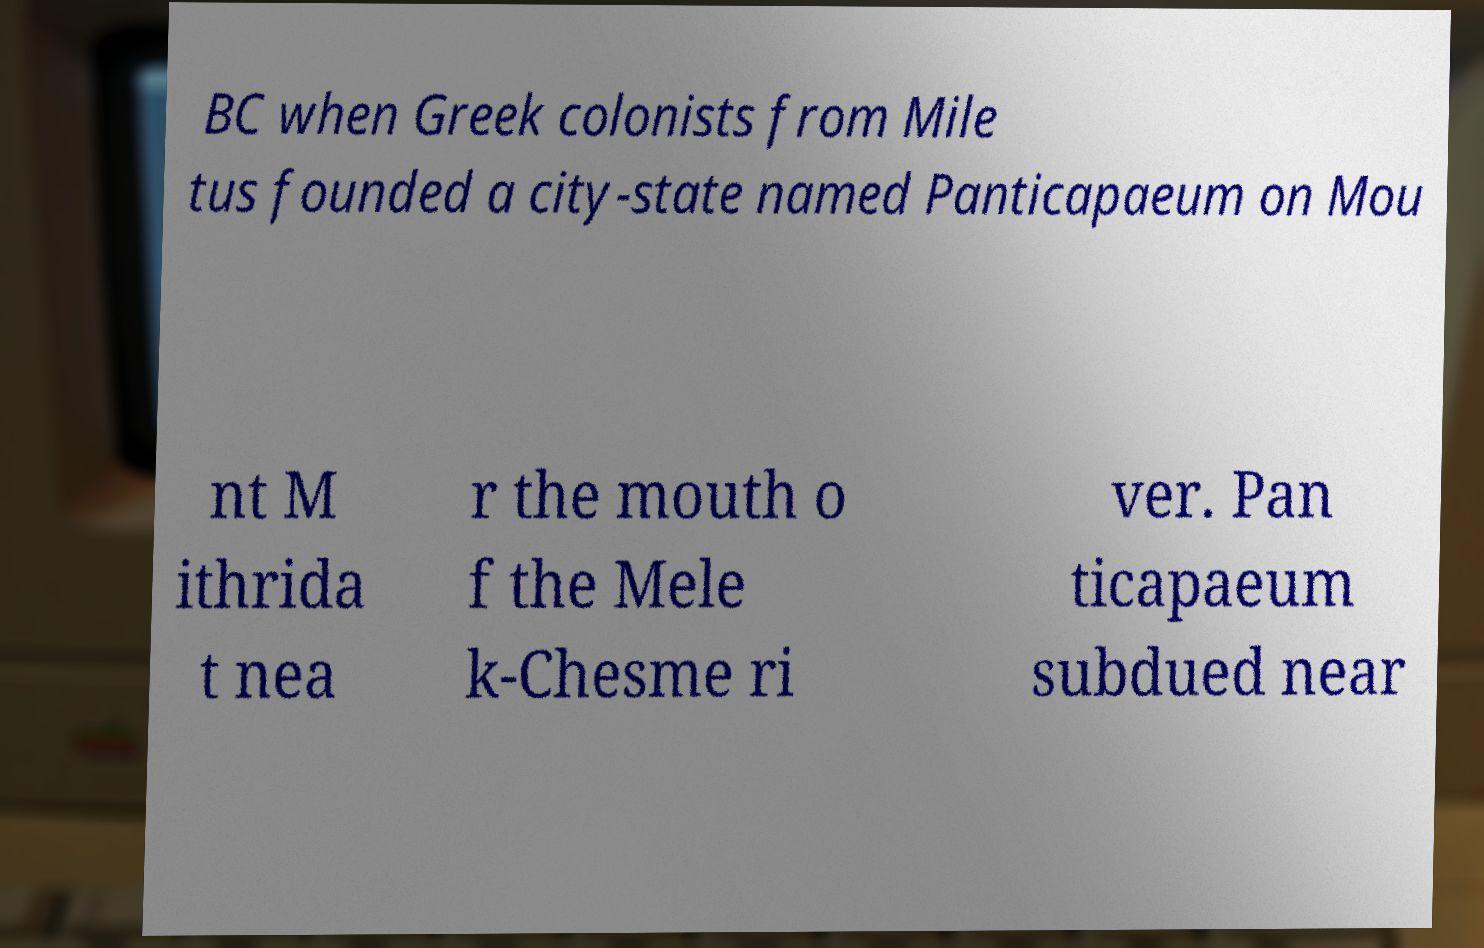Could you assist in decoding the text presented in this image and type it out clearly? BC when Greek colonists from Mile tus founded a city-state named Panticapaeum on Mou nt M ithrida t nea r the mouth o f the Mele k-Chesme ri ver. Pan ticapaeum subdued near 